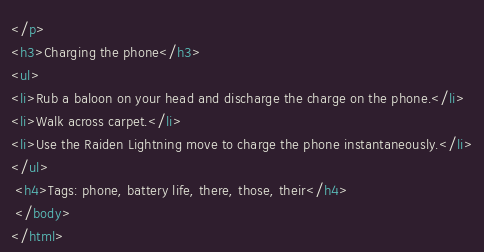<code> <loc_0><loc_0><loc_500><loc_500><_HTML_></p>
<h3>Charging the phone</h3>
<ul>
<li>Rub a baloon on your head and discharge the charge on the phone.</li>
<li>Walk across carpet.</li>
<li>Use the Raiden Lightning move to charge the phone instantaneously.</li>
</ul>
 <h4>Tags: phone, battery life, there, those, their</h4>
 </body>
</html></code> 